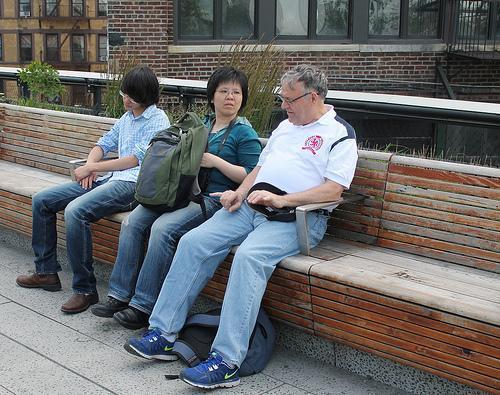How many people are in the picture?
Give a very brief answer. 3. How many people are wearing glasses?
Give a very brief answer. 2. 